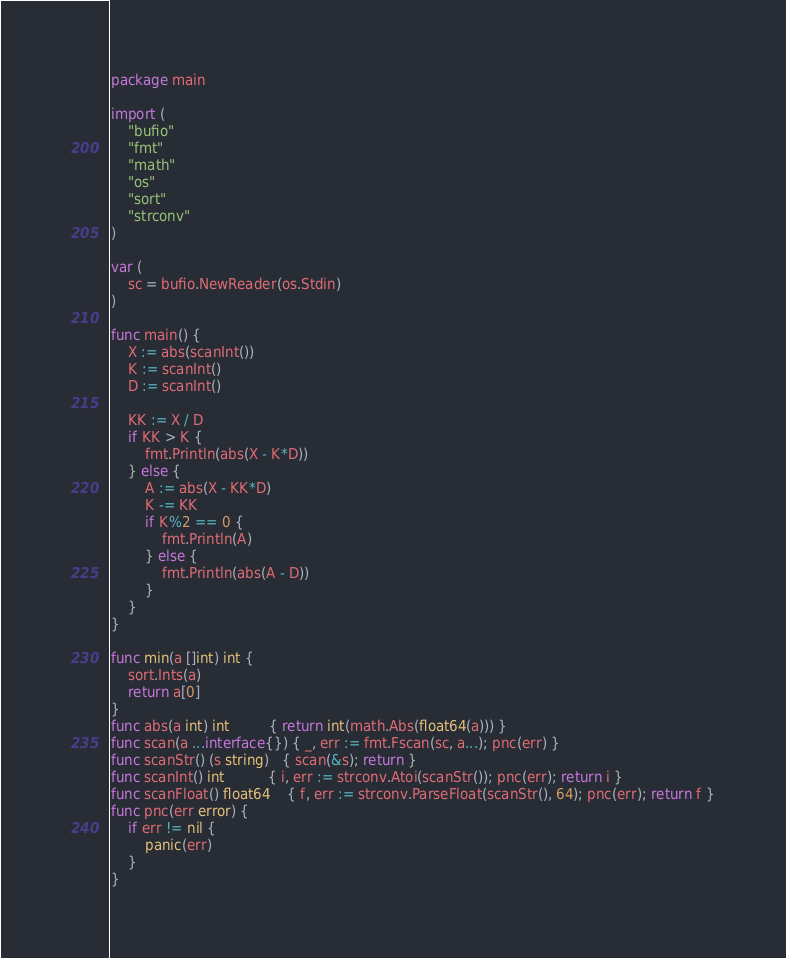Convert code to text. <code><loc_0><loc_0><loc_500><loc_500><_Go_>package main

import (
	"bufio"
	"fmt"
	"math"
	"os"
	"sort"
	"strconv"
)

var (
	sc = bufio.NewReader(os.Stdin)
)

func main() {
	X := abs(scanInt())
	K := scanInt()
	D := scanInt()

	KK := X / D
	if KK > K {
		fmt.Println(abs(X - K*D))
	} else {
		A := abs(X - KK*D)
		K -= KK
		if K%2 == 0 {
			fmt.Println(A)
		} else {
			fmt.Println(abs(A - D))
		}
	}
}

func min(a []int) int {
	sort.Ints(a)
	return a[0]
}
func abs(a int) int         { return int(math.Abs(float64(a))) }
func scan(a ...interface{}) { _, err := fmt.Fscan(sc, a...); pnc(err) }
func scanStr() (s string)   { scan(&s); return }
func scanInt() int          { i, err := strconv.Atoi(scanStr()); pnc(err); return i }
func scanFloat() float64    { f, err := strconv.ParseFloat(scanStr(), 64); pnc(err); return f }
func pnc(err error) {
	if err != nil {
		panic(err)
	}
}
</code> 